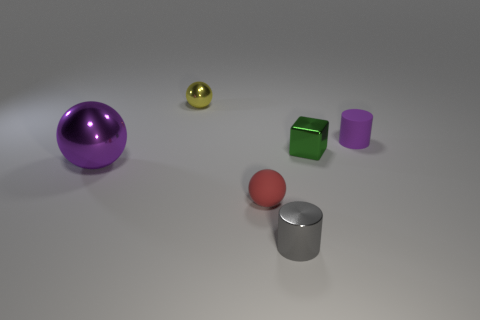Subtract all red spheres. How many spheres are left? 2 Subtract 1 balls. How many balls are left? 2 Add 3 red rubber spheres. How many objects exist? 9 Subtract all green balls. Subtract all cyan cylinders. How many balls are left? 3 Subtract all cylinders. How many objects are left? 4 Add 3 large green cylinders. How many large green cylinders exist? 3 Subtract 1 green cubes. How many objects are left? 5 Subtract all large shiny balls. Subtract all tiny gray shiny things. How many objects are left? 4 Add 5 small yellow objects. How many small yellow objects are left? 6 